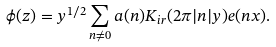<formula> <loc_0><loc_0><loc_500><loc_500>\phi ( z ) = y ^ { 1 / 2 } \sum _ { n \neq 0 } a ( n ) K _ { i r } ( 2 \pi | n | y ) e ( n x ) .</formula> 